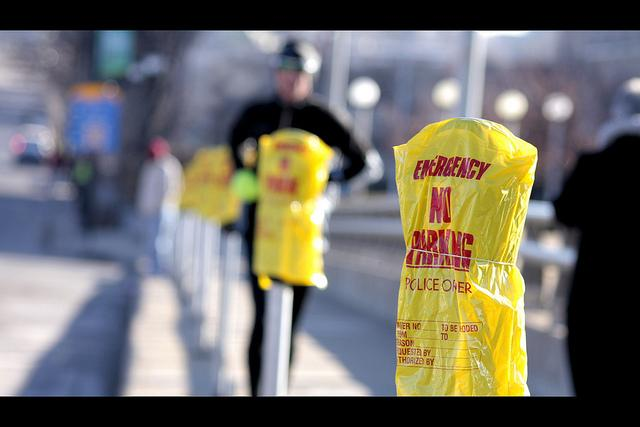What might be happening on this street? Please explain your reasoning. parade. People shouldn't be parking on a street when there is an event on that street. 